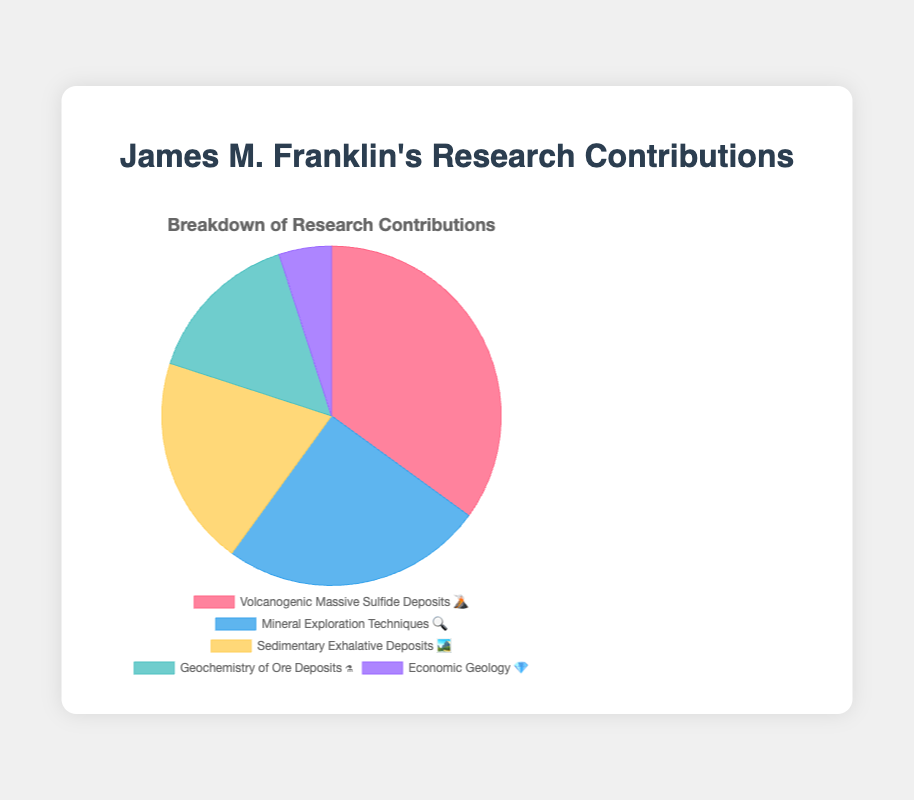Which field has the highest percentage of James M. Franklin's research contributions? The highest percentage in the pie chart is 35%, which corresponds to Volcanogenic Massive Sulfide Deposits 🌋.
Answer: Volcanogenic Massive Sulfide Deposits 🌋 What percentage of James M. Franklin's contributions is in Economic Geology 💎? By examining the chart, the slice labeled Economic Geology 💎 represents 5% of the total contributions.
Answer: 5% How many different fields are represented in his research contributions? The pie chart shows five different slices, one for each field, labeled with unique emojis.
Answer: 5 What is the combined percentage of contributions in Sedimentary Exhalative Deposits 🏞️ and Geochemistry of Ore Deposits ⚗️? Add the percentages of Sedimentary Exhalative Deposits (20%) and Geochemistry of Ore Deposits (15%). Therefore, 20% + 15% = 35%.
Answer: 35% Which field with its emoji symbol ranks second highest in his research contributions? The second-largest slice, at 25%, is Mineral Exploration Techniques 🔍.
Answer: Mineral Exploration Techniques 🔍 What is the difference in percentage between the highest and lowest contribution fields? The highest contribution is 35% (Volcanogenic Massive Sulfide Deposits 🌋) and the lowest is 5% (Economic Geology 💎). The difference is 35% - 5% = 30%.
Answer: 30% How many fields have a contribution percentage of 20% or more? By analyzing the chart, three fields meet this criteria: Volcanogenic Massive Sulfide Deposits 🌋 (35%), Mineral Exploration Techniques 🔍 (25%), and Sedimentary Exhalative Deposits 🏞️ (20%).
Answer: 3 Does the contribution in Mineral Exploration Techniques 🔍 exceed that in Geochemistry of Ore Deposits ⚗️? Yes, Mineral Exploration Techniques 🔍 is at 25%, which is greater than the 15% for Geochemistry of Ore Deposits ⚗️.
Answer: Yes 